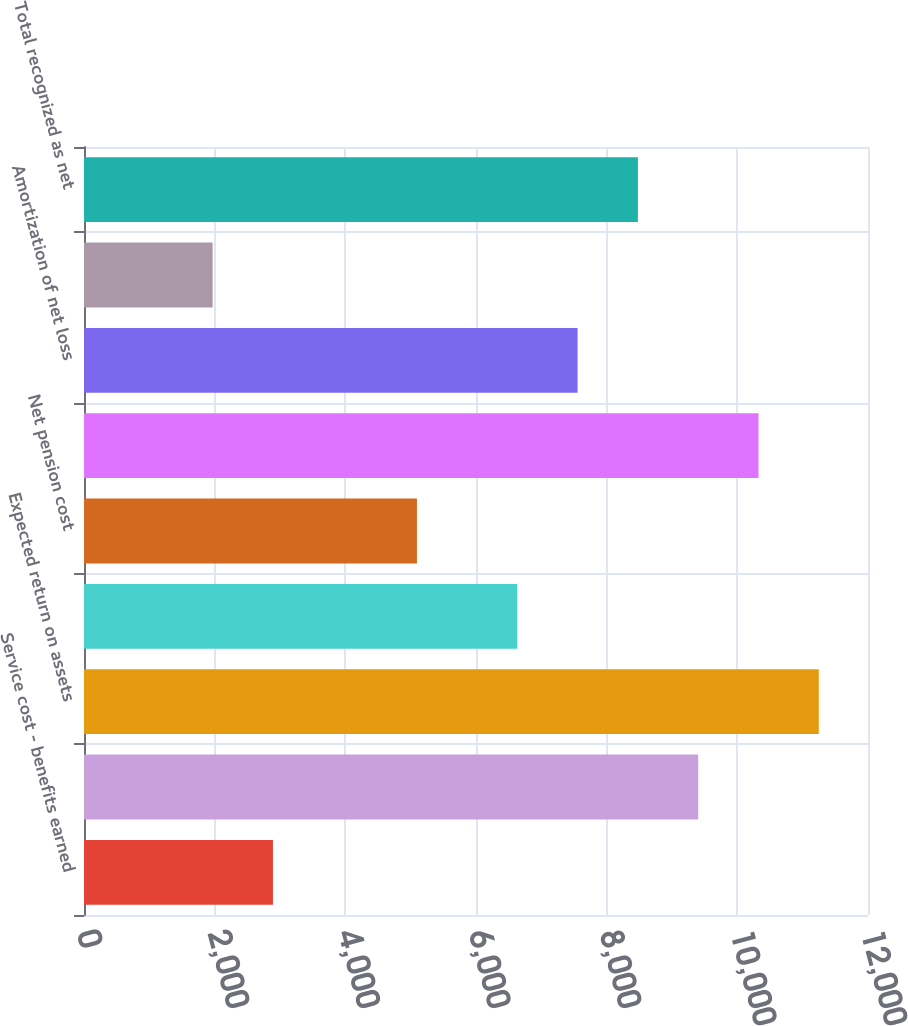Convert chart. <chart><loc_0><loc_0><loc_500><loc_500><bar_chart><fcel>Service cost - benefits earned<fcel>Interest cost on projected<fcel>Expected return on assets<fcel>Recognized net loss<fcel>Net pension cost<fcel>Net loss<fcel>Amortization of net loss<fcel>Total<fcel>Total recognized as net<nl><fcel>2892<fcel>9401<fcel>11247<fcel>6632<fcel>5096<fcel>10324<fcel>7555<fcel>1969<fcel>8478<nl></chart> 